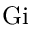Convert formula to latex. <formula><loc_0><loc_0><loc_500><loc_500>G i</formula> 